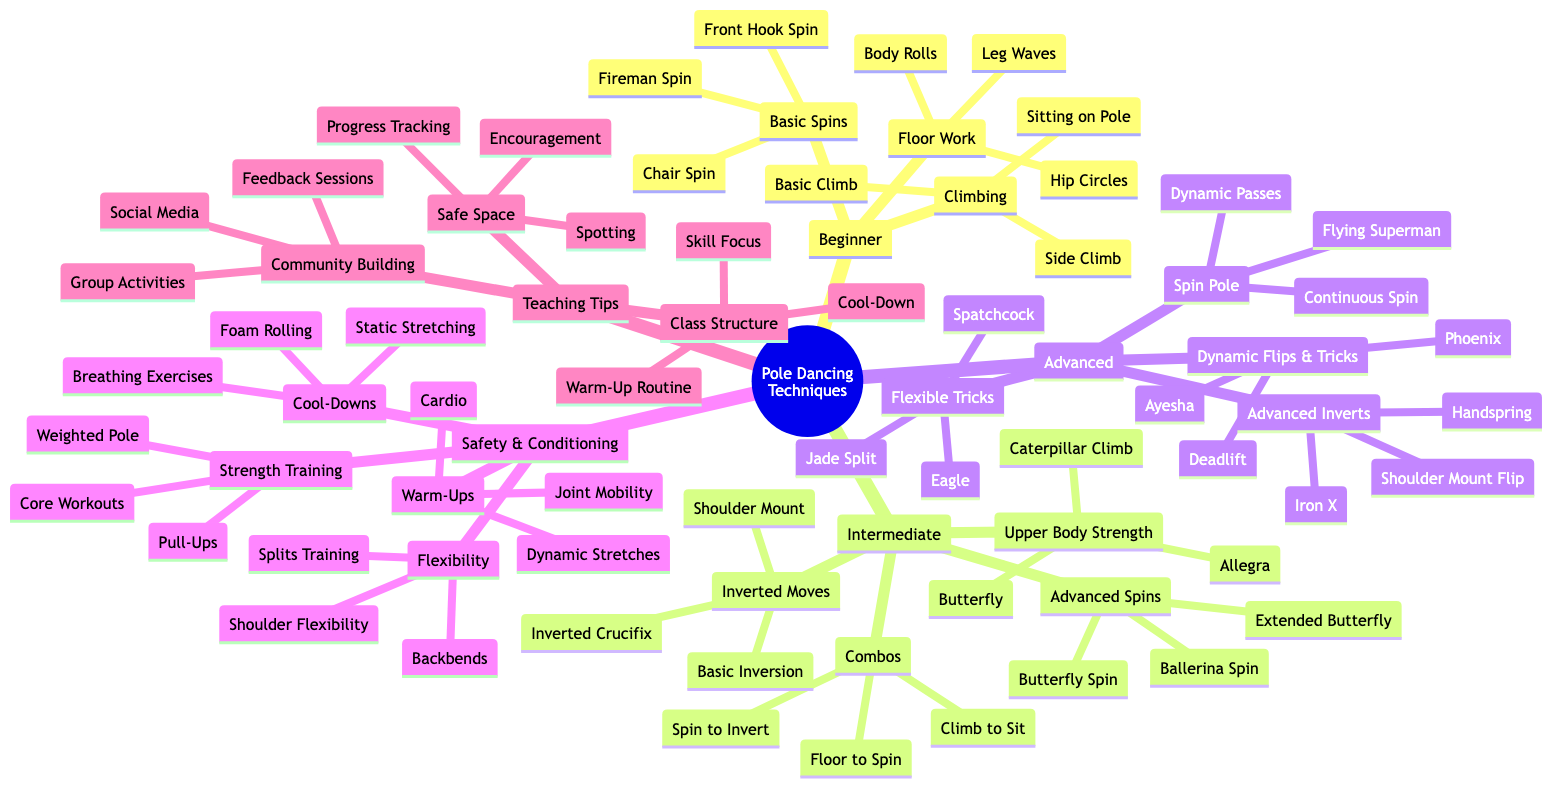What are the three categories in Beginner Techniques? The category of Beginner Techniques has three subcategories: Basic Spins, Climbing Techniques, and Floor Work. Each of these subcategories contains specific techniques that are designed for beginners in pole dancing.
Answer: Basic Spins, Climbing Techniques, Floor Work How many Advanced Inverts techniques are listed? The Advanced Techniques section contains a subcategory called Advanced Inverts which includes three techniques: Iron X, Shoulder Mount Flip, and Handspring. Therefore, the total is three techniques.
Answer: 3 Which technique is part of the Intermediate Upper Body Strength Moves? In the Intermediate Techniques category, there is a subcategory for Upper Body Strength Moves that includes Allegra, Butterfly, and Caterpillar Climb. Any of these can be a correct technique mentioned, but the most straightforward answer is to name one of them directly.
Answer: Allegra What are the two types of exercises included in Safety and Conditioning? The Safety and Conditioning section contains four subcategories: Warm-Ups, Strength Training, Flexibility Exercises, and Cool-Downs. From these, we can choose any two categories, such as Warm-Ups and Strength Training.
Answer: Warm-Ups, Strength Training Name one Advanced Dynamic Flip & Trick listed. The Advanced Techniques category has a subcategory named Dynamic Flips & Tricks, which includes Ayesha, Phoenix, and Deadlift. Any of these could serve as a valid example.
Answer: Ayesha Which pole dancing technique requires the highest level of skill, according to the diagram? The Advanced Techniques category contains the most advanced skills including techniques such as Iron X, Shoulder Mount Flip, and Handspring, which are indicated as being advanced. Thus, any of these could represent the highest skill level.
Answer: Iron X How many techniques are listed under Intermediate Combos? The Intermediate Techniques section includes a subcategory called Combos with three techniques: Spin to Invert Combo, Climb to Sit Combo, and Floor Work to Spin Combo. Thus, the number of listed techniques is three.
Answer: 3 What is the focus of the Class Structure in Teaching Tips? The Teaching Tips section lists Class Structure with three aspects: Warm-Up Routine, Skill Focus Segment, and Cool-Down Routine. Hence, the focus can be derived from any of these sequential parts that form the structure of a class.
Answer: Warm-Up Routine, Skill Focus Segment, Cool-Down Routine What are the two types of Warm-Ups addressed in Safety and Conditioning? The Warm-Ups subcategory in Safety and Conditioning has three different types: Joint Mobility, Dynamic Stretches, and Cardio Warm-Up. Therefore, any two types—like Joint Mobility and Dynamic Stretches—could provide a correct answer to this question.
Answer: Joint Mobility, Dynamic Stretches 